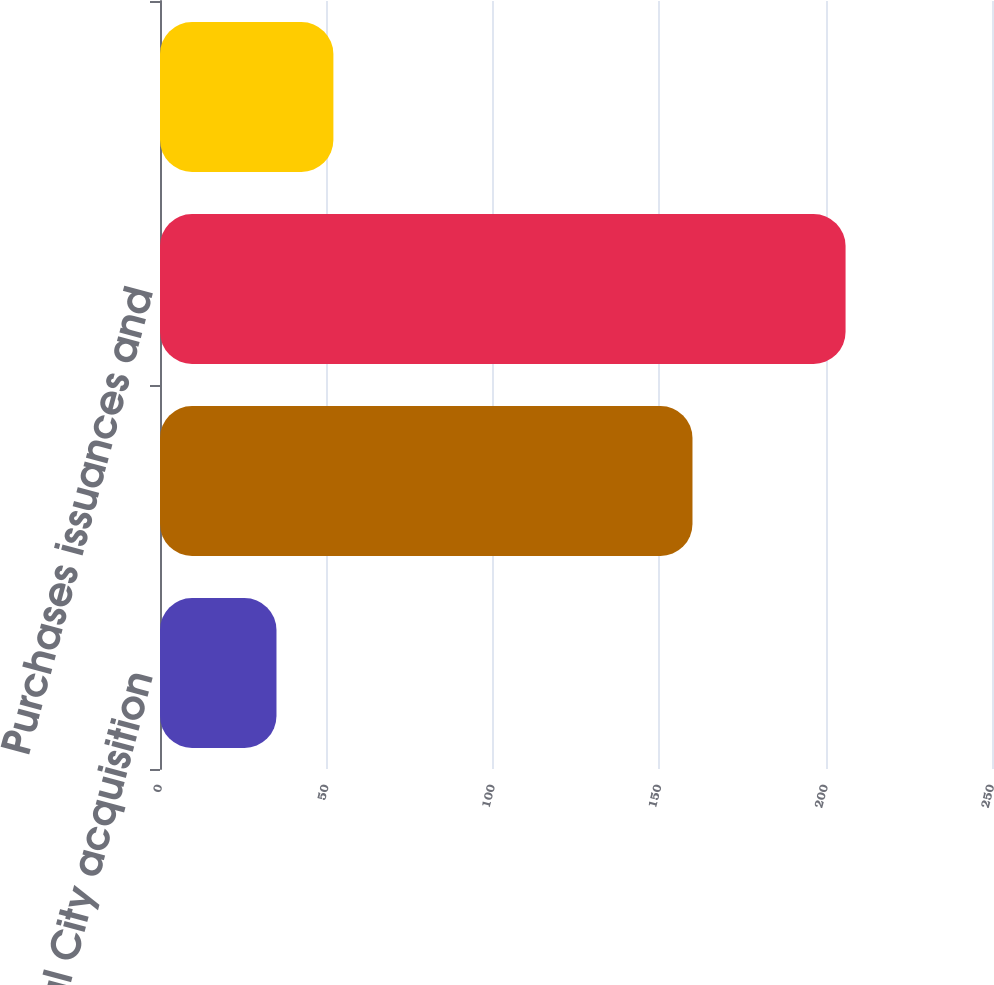Convert chart. <chart><loc_0><loc_0><loc_500><loc_500><bar_chart><fcel>National City acquisition<fcel>January 1 2009<fcel>Purchases issuances and<fcel>December 31 2009<nl><fcel>35<fcel>160<fcel>206<fcel>52.1<nl></chart> 